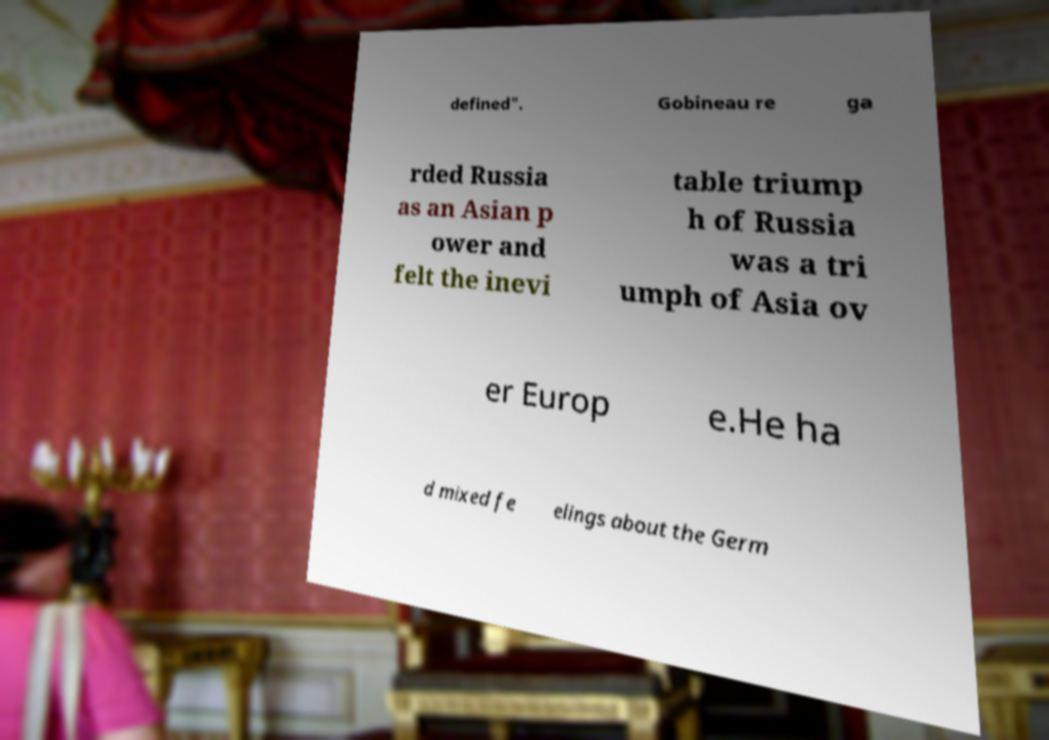Please identify and transcribe the text found in this image. defined". Gobineau re ga rded Russia as an Asian p ower and felt the inevi table triump h of Russia was a tri umph of Asia ov er Europ e.He ha d mixed fe elings about the Germ 